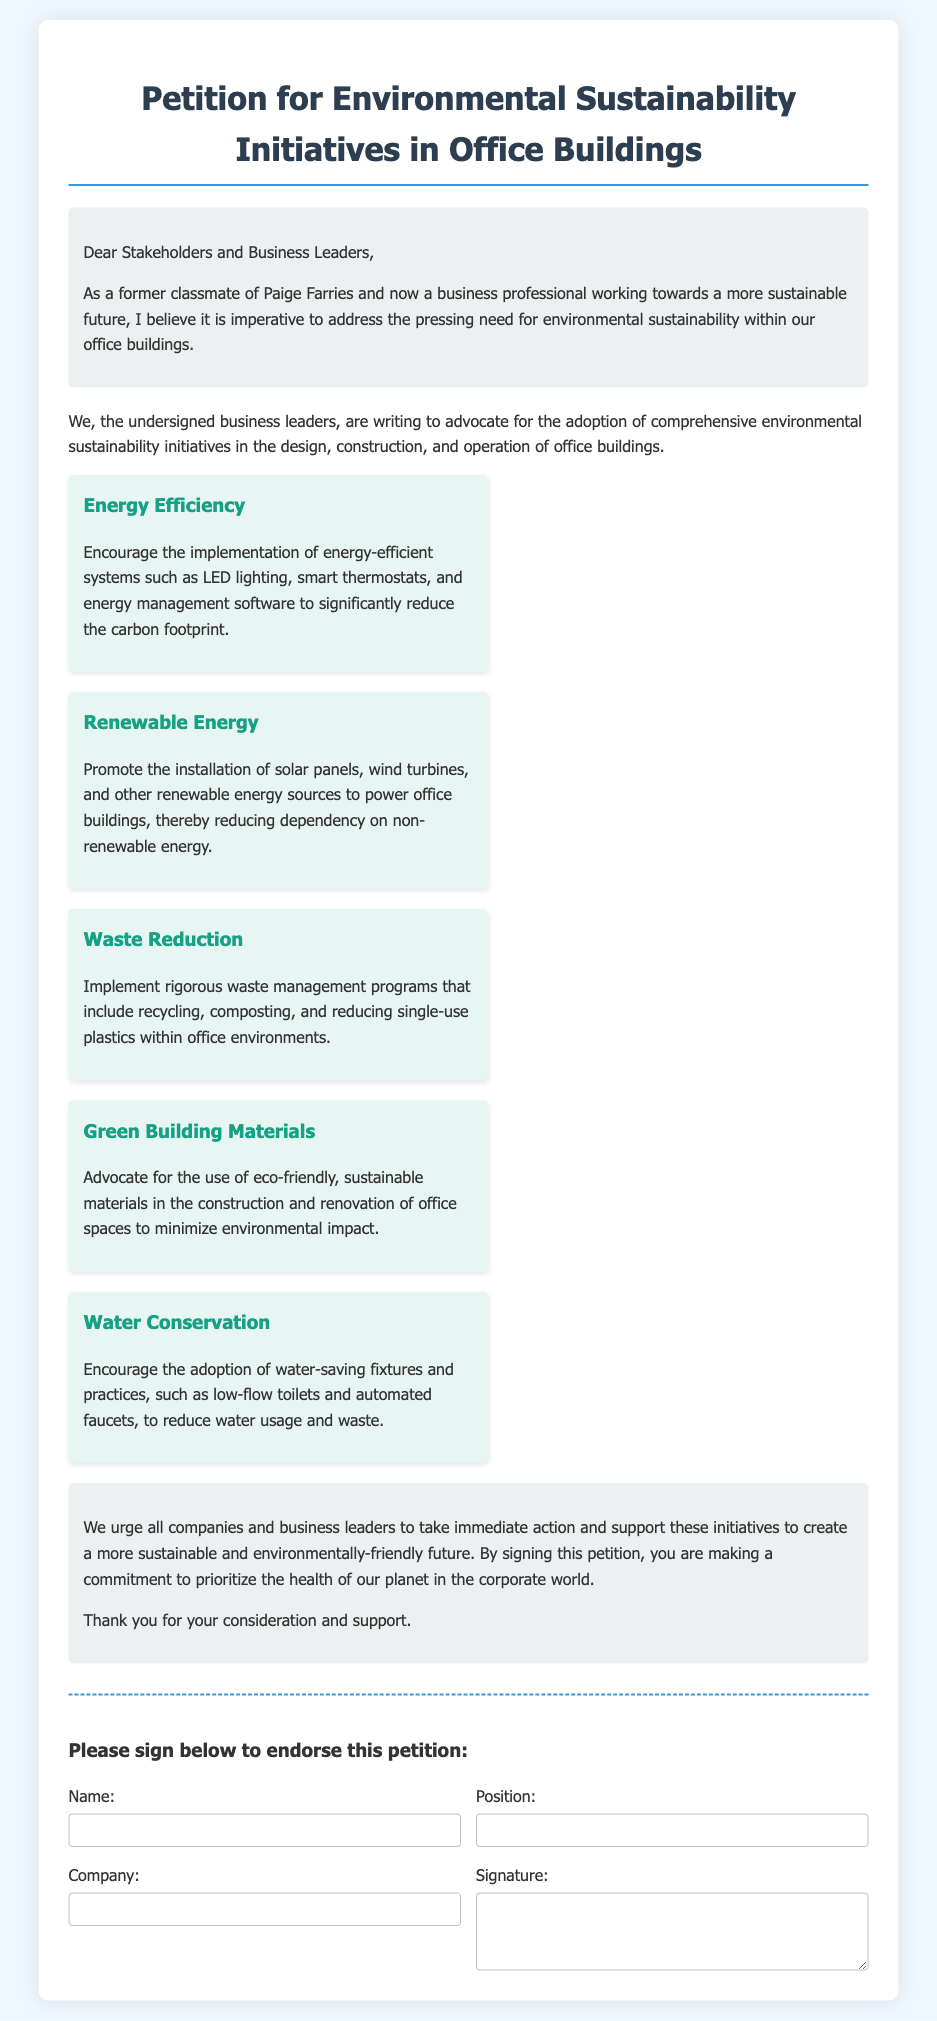What is the title of the petition? The title of the petition is clearly stated at the top of the document.
Answer: Petition for Environmental Sustainability Initiatives in Office Buildings Who are the main advocates of the petition? The introduction mentions the signers as business leaders advocating for sustainability initiatives.
Answer: Business leaders What is one key area focused on in the petition? Each key point highlighted in the document presents a specific area of focus related to sustainability.
Answer: Energy Efficiency What does the petition encourage regarding energy sources? The document emphasizes promoting the installation of renewable energy sources in office buildings.
Answer: Renewable Energy What is one practice suggested for waste management? The petition includes a specific initiative related to reducing certain types of waste in the office context.
Answer: Reducing single-use plastics How many key points are listed in the document? The document enumerates key sustainability initiatives which can be counted directly.
Answer: Five What action is the petition urging companies to take? The conclusion outlines a specific call to action in support of certain initiatives, which the document aims to promote.
Answer: Immediate action What is required for a person to endorse the petition? The signature section specifies what details are needed from individuals who wish to endorse the petition.
Answer: Name, position, company, signature 